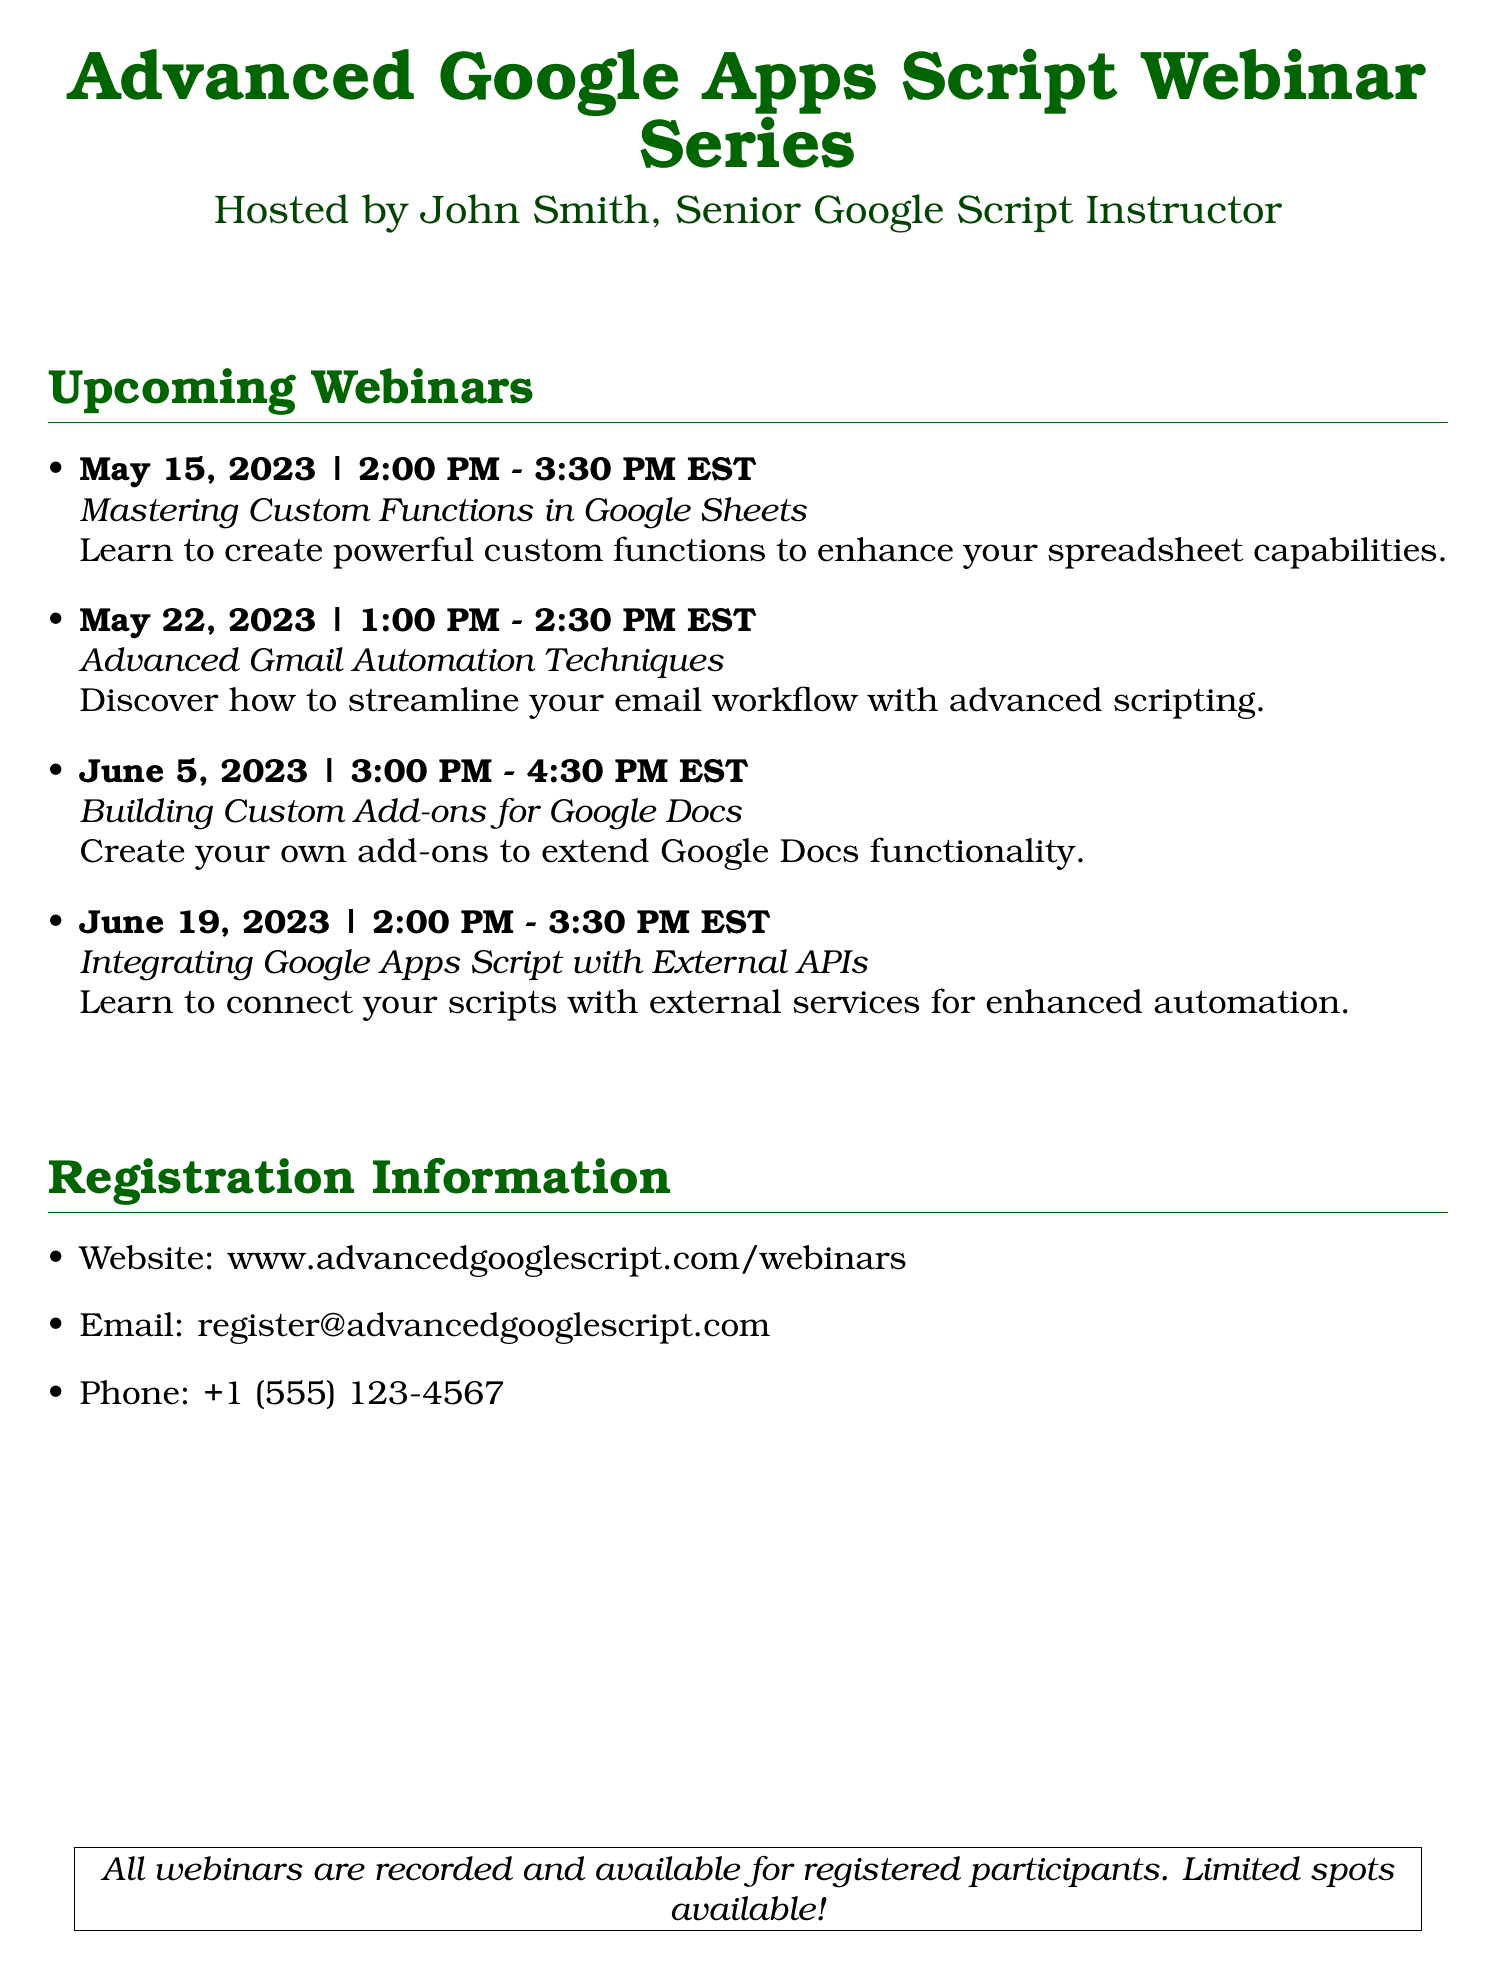What is the title of the webinar on May 15, 2023? The title of the webinar is stated right below the date in the document.
Answer: Mastering Custom Functions in Google Sheets Who is hosting the webinar series? The host's name is mentioned in the introduction at the beginning of the document.
Answer: John Smith How long is the webinar on June 19, 2023? The duration of the webinar is given alongside the date in the item list.
Answer: 1.5 hours What is the email address for registration? The email address for registration is provided under the registration information section.
Answer: register@advancedgooglescript.com Which day is the webinar on Advanced Gmail Automation Techniques scheduled? The specific weekday can be found by checking the date of that webinar in the document.
Answer: Tuesday What time does the webinar on Building Custom Add-ons for Google Docs start? The starting time is specified in the item list next to the date of the webinar.
Answer: 3:00 PM How many webinars are listed in total? The total count of webinars can be determined by counting the items in the upcoming webinars section.
Answer: 4 What is the website for webinar registration? The website is clearly stated in the registration information section of the document.
Answer: www.advancedgooglescript.com/webinars 